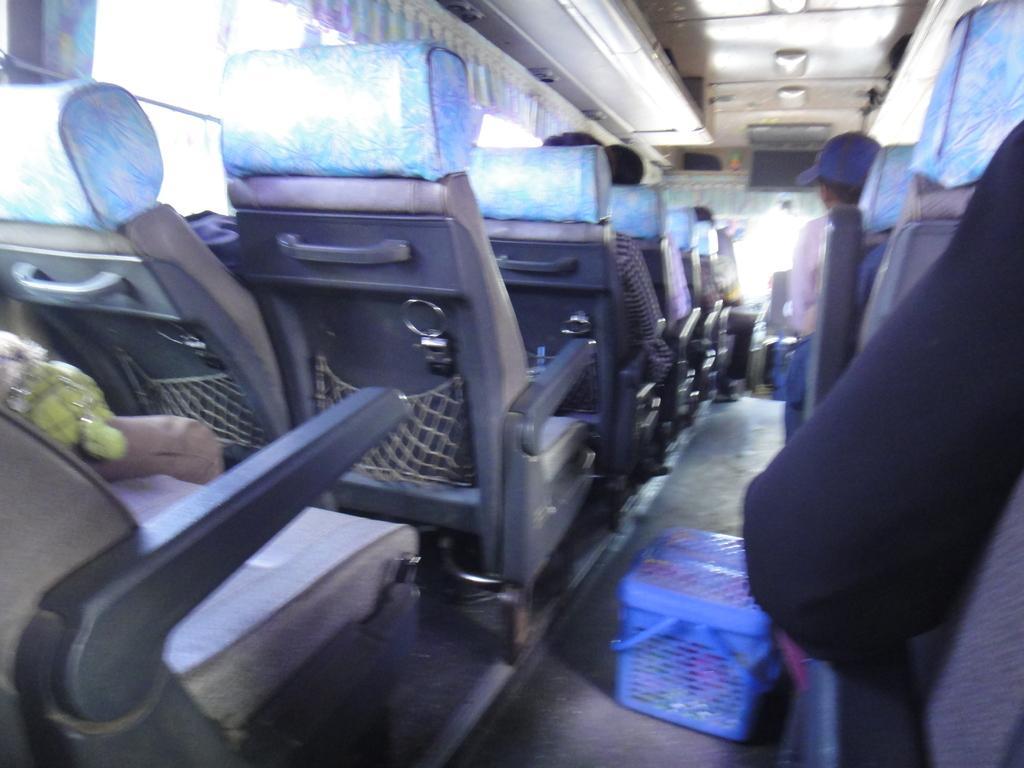Please provide a concise description of this image. This picture is taken inside a vehicle having few seats. Few persons are sitting on the seats. There is a basket on the floor. A person is wearing a cap. Left side there are few windows covered with curtain. 